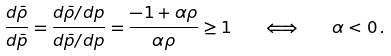<formula> <loc_0><loc_0><loc_500><loc_500>\frac { d \bar { \rho } } { d \bar { p } } = \frac { d \bar { \rho } / d p } { d \bar { p } / d p } = \frac { - 1 + \alpha \rho } { \alpha \rho } \geq 1 \quad \Longleftrightarrow \quad \alpha < 0 \, .</formula> 